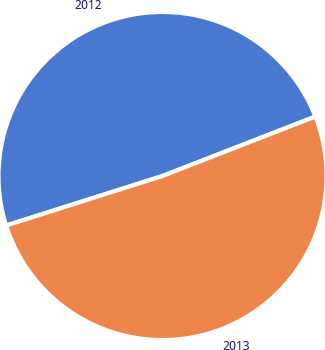Convert chart to OTSL. <chart><loc_0><loc_0><loc_500><loc_500><pie_chart><fcel>2012<fcel>2013<nl><fcel>48.98%<fcel>51.02%<nl></chart> 